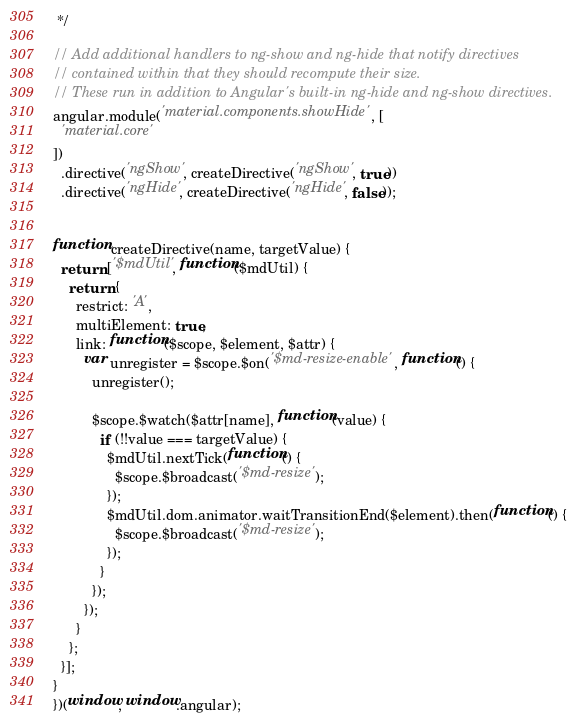<code> <loc_0><loc_0><loc_500><loc_500><_JavaScript_> */

// Add additional handlers to ng-show and ng-hide that notify directives
// contained within that they should recompute their size.
// These run in addition to Angular's built-in ng-hide and ng-show directives.
angular.module('material.components.showHide', [
  'material.core'
])
  .directive('ngShow', createDirective('ngShow', true))
  .directive('ngHide', createDirective('ngHide', false));


function createDirective(name, targetValue) {
  return ['$mdUtil', function($mdUtil) {
    return {
      restrict: 'A',
      multiElement: true,
      link: function($scope, $element, $attr) {
        var unregister = $scope.$on('$md-resize-enable', function() {
          unregister();

          $scope.$watch($attr[name], function(value) {
            if (!!value === targetValue) {
              $mdUtil.nextTick(function() {
                $scope.$broadcast('$md-resize');
              });
              $mdUtil.dom.animator.waitTransitionEnd($element).then(function() {
                $scope.$broadcast('$md-resize');
              });
            }
          });
        });
      }
    };
  }];
}
})(window, window.angular);</code> 